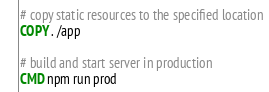Convert code to text. <code><loc_0><loc_0><loc_500><loc_500><_Dockerfile_>
# copy static resources to the specified location
COPY . /app

# build and start server in production
CMD npm run prod
</code> 